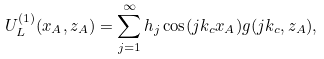Convert formula to latex. <formula><loc_0><loc_0><loc_500><loc_500>U ^ { ( 1 ) } _ { L } ( x _ { A } , z _ { A } ) = \sum _ { j = 1 } ^ { \infty } h _ { j } \cos ( j k _ { c } x _ { A } ) g ( j k _ { c } , z _ { A } ) ,</formula> 